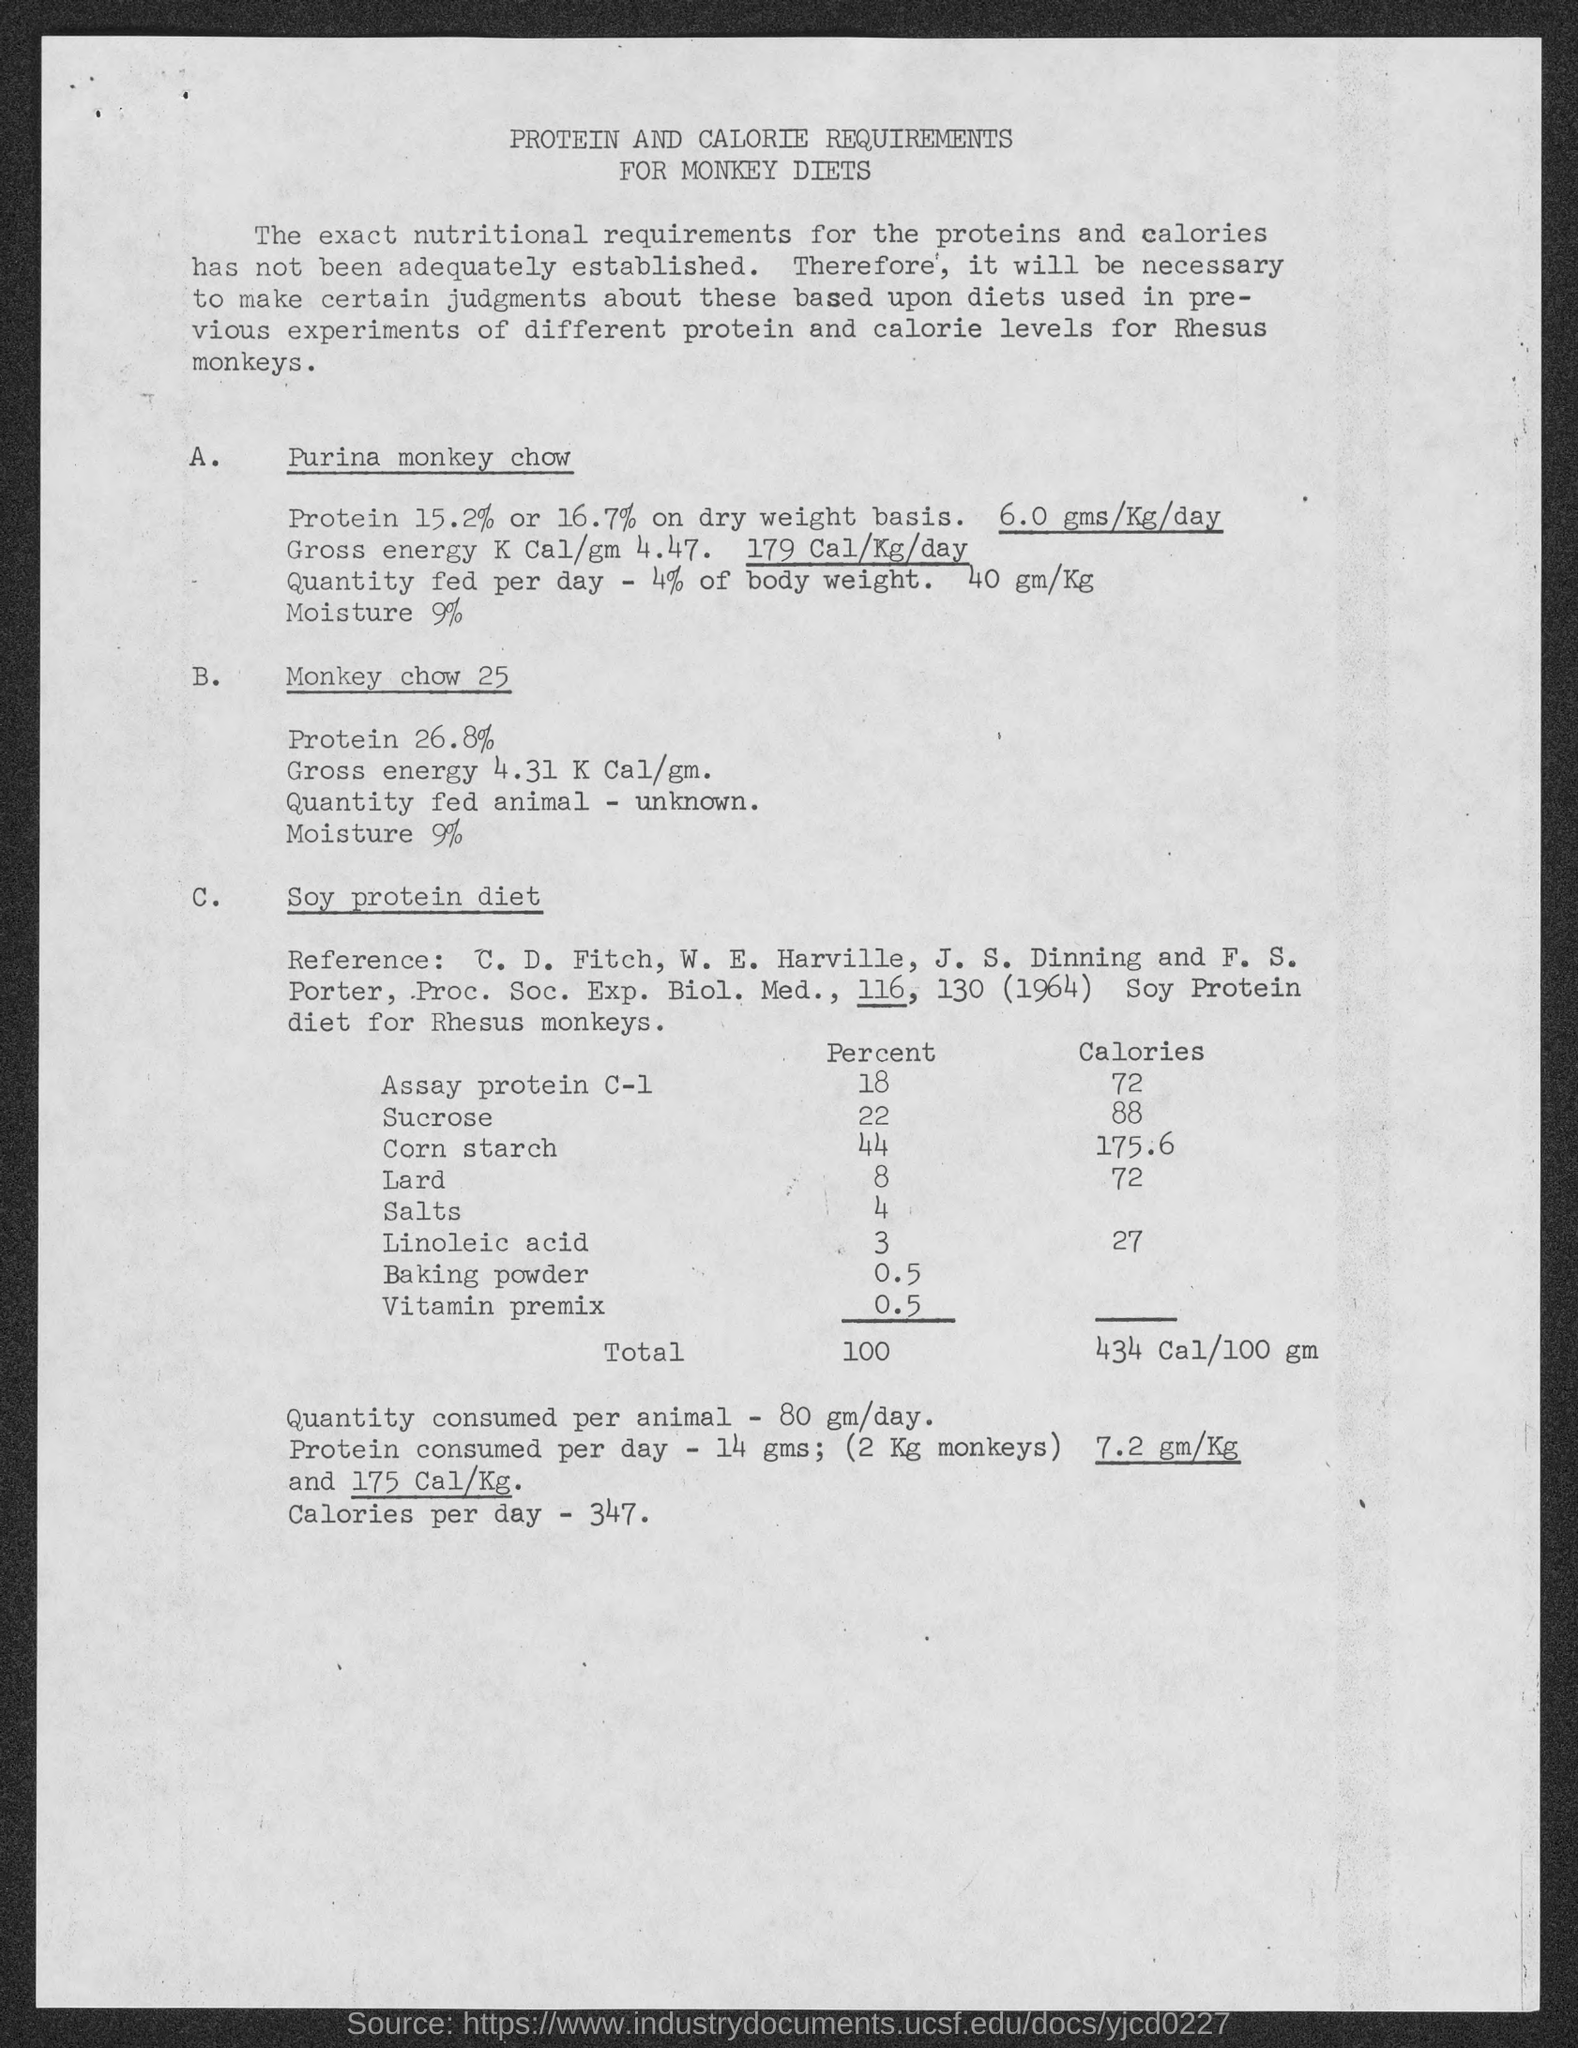Specify some key components in this picture. The quantity consumed per animal is 80 grams per day. The recommended daily caloric intake is 347 calories per day. The title of the document is 'Protein and Calorie Requirements for Monkey Diets.' On average, individuals consume approximately 14 grams of protein per day. 